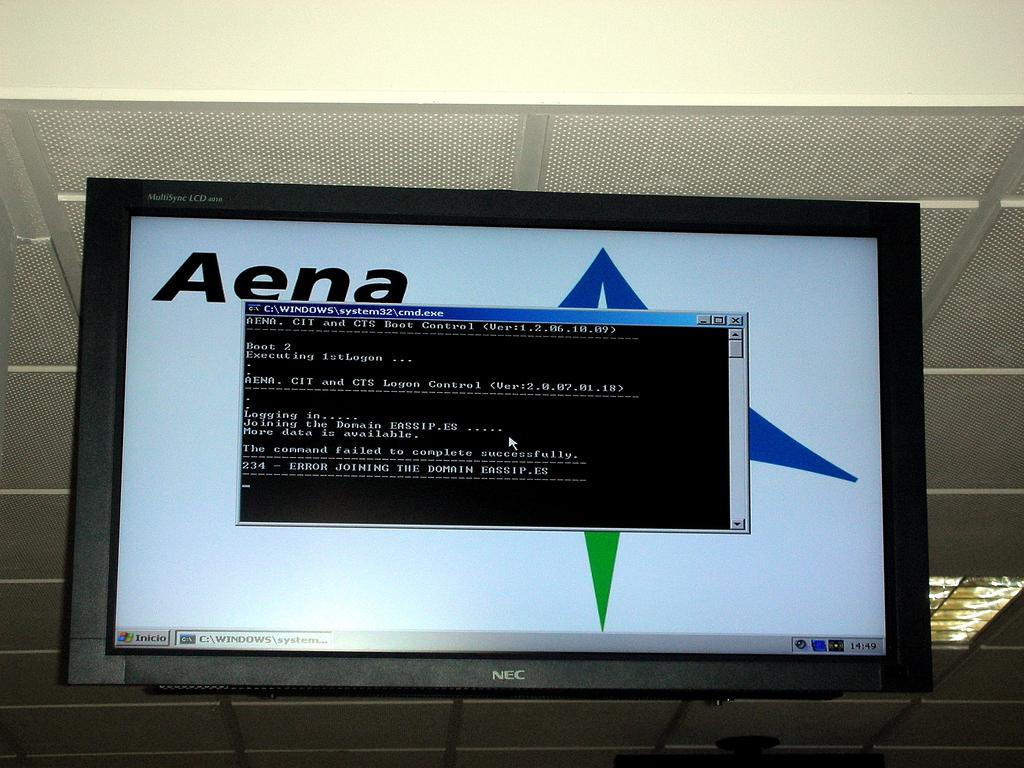<image>
Render a clear and concise summary of the photo. An NEC monitor displays an Aena desktop with a command prompt window open. 